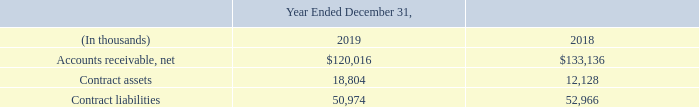Contract Assets and Liabilities
The following table provides information about receivables, contract assets and contract liabilities from our revenue contracts with customers:
Contract assets include costs that are incremental to the acquisition of a contract. Incremental costs are those that result directly from obtaining a contract or costs that would not have been incurred if the contract had not been obtained, which primarily relate to sales commissions. These costs are deferred and amortized over the expected customer life.
We determined that the expected customer life is the expected period of benefit as the commission on the renewal contract is not commensurate with the commission on the initial contract. During the years ended December 31, 2019 and 2018, the Company recognized expense of $6.3 million and $2.9 million, respectively, related to deferred contract acquisition costs.
Contract liabilities include deferred revenues related to advanced payments for services and nonrefundable, upfront service activation and set-up fees, which under the new standard are generally deferred and amortized over the expected customer life as the option to renew without paying an upfront fee provides the customer with a material right. During the years ended December 31, 2019 and 2018, the Company deferred and recognized revenues of $397.5 million and $354.2 million, respectively.
A receivable is recognized in the period the Company provides goods or services when the Company’s right to consideration is unconditional. Payment terms on invoiced amounts are generally 30 to 60 days.
What was the expense recognized by the company in 2019? $6.3 million. What was the deferred and recognized revenue in 2019? $397.5 million. What is the number of days for the payment terms on invoiced amounts? 30 to 60 days. What is the accounts receivable, net increase / (decrease) from 2018 to 2019?
Answer scale should be: thousand. 120,016 - 133,136
Answer: -13120. What was the percentage increase / (decrease) in the contract assets from 2018 to 2019?
Answer scale should be: percent. 18,804 / 12,128 - 1
Answer: 55.05. What is the average contract liabilities for 2018 and 2019?
Answer scale should be: thousand. (50,974 + 52,966) / 2
Answer: 51970. 